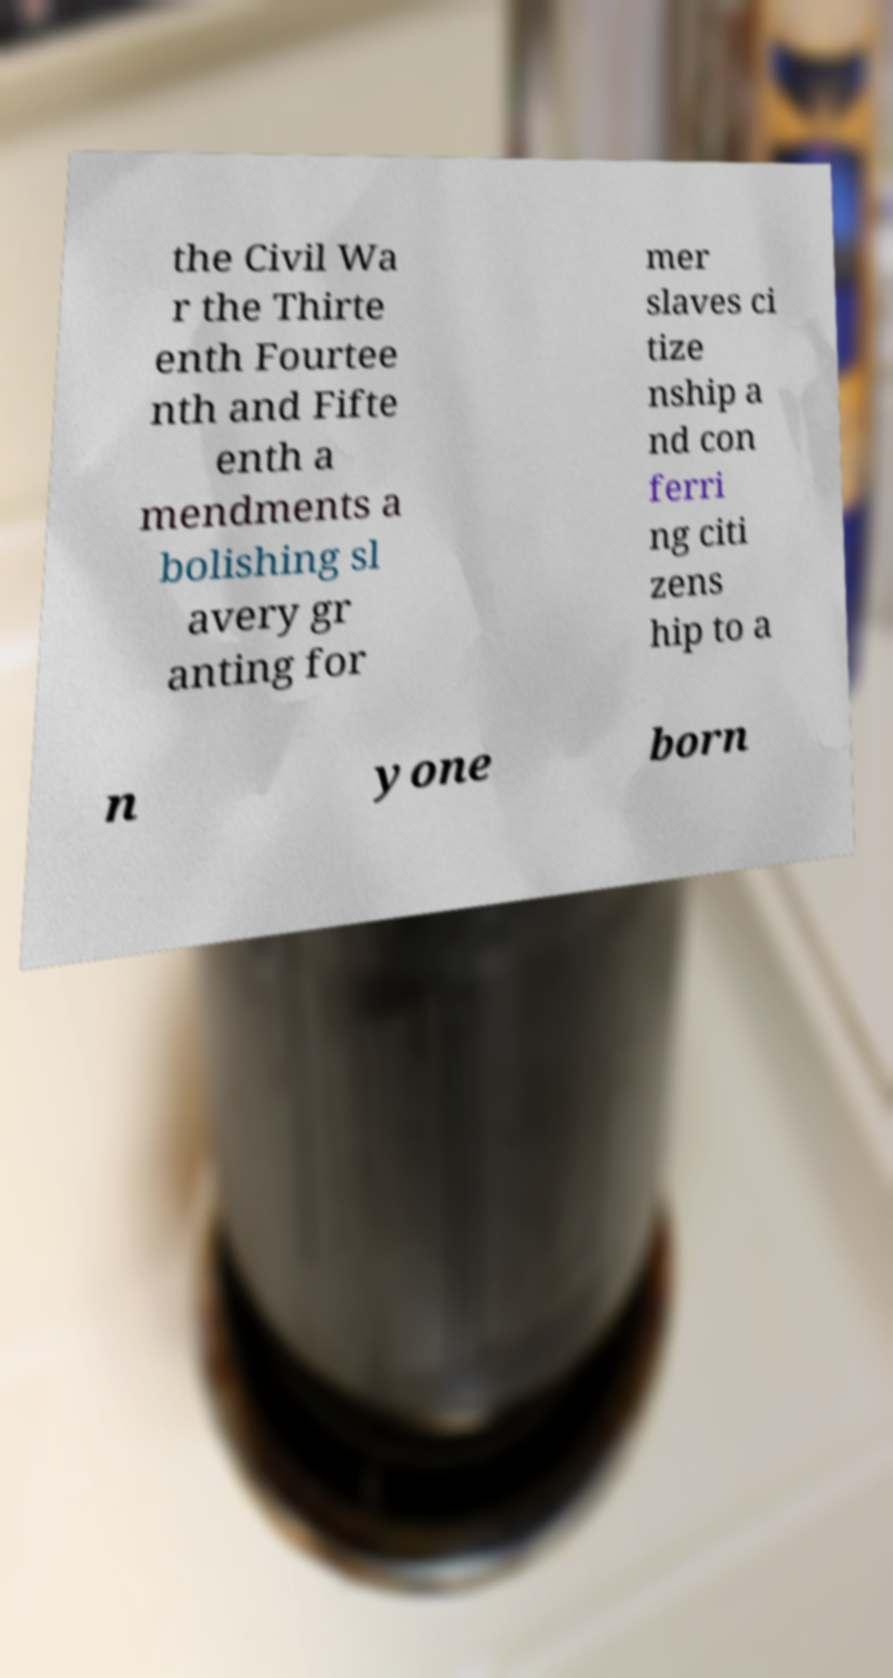Could you extract and type out the text from this image? the Civil Wa r the Thirte enth Fourtee nth and Fifte enth a mendments a bolishing sl avery gr anting for mer slaves ci tize nship a nd con ferri ng citi zens hip to a n yone born 